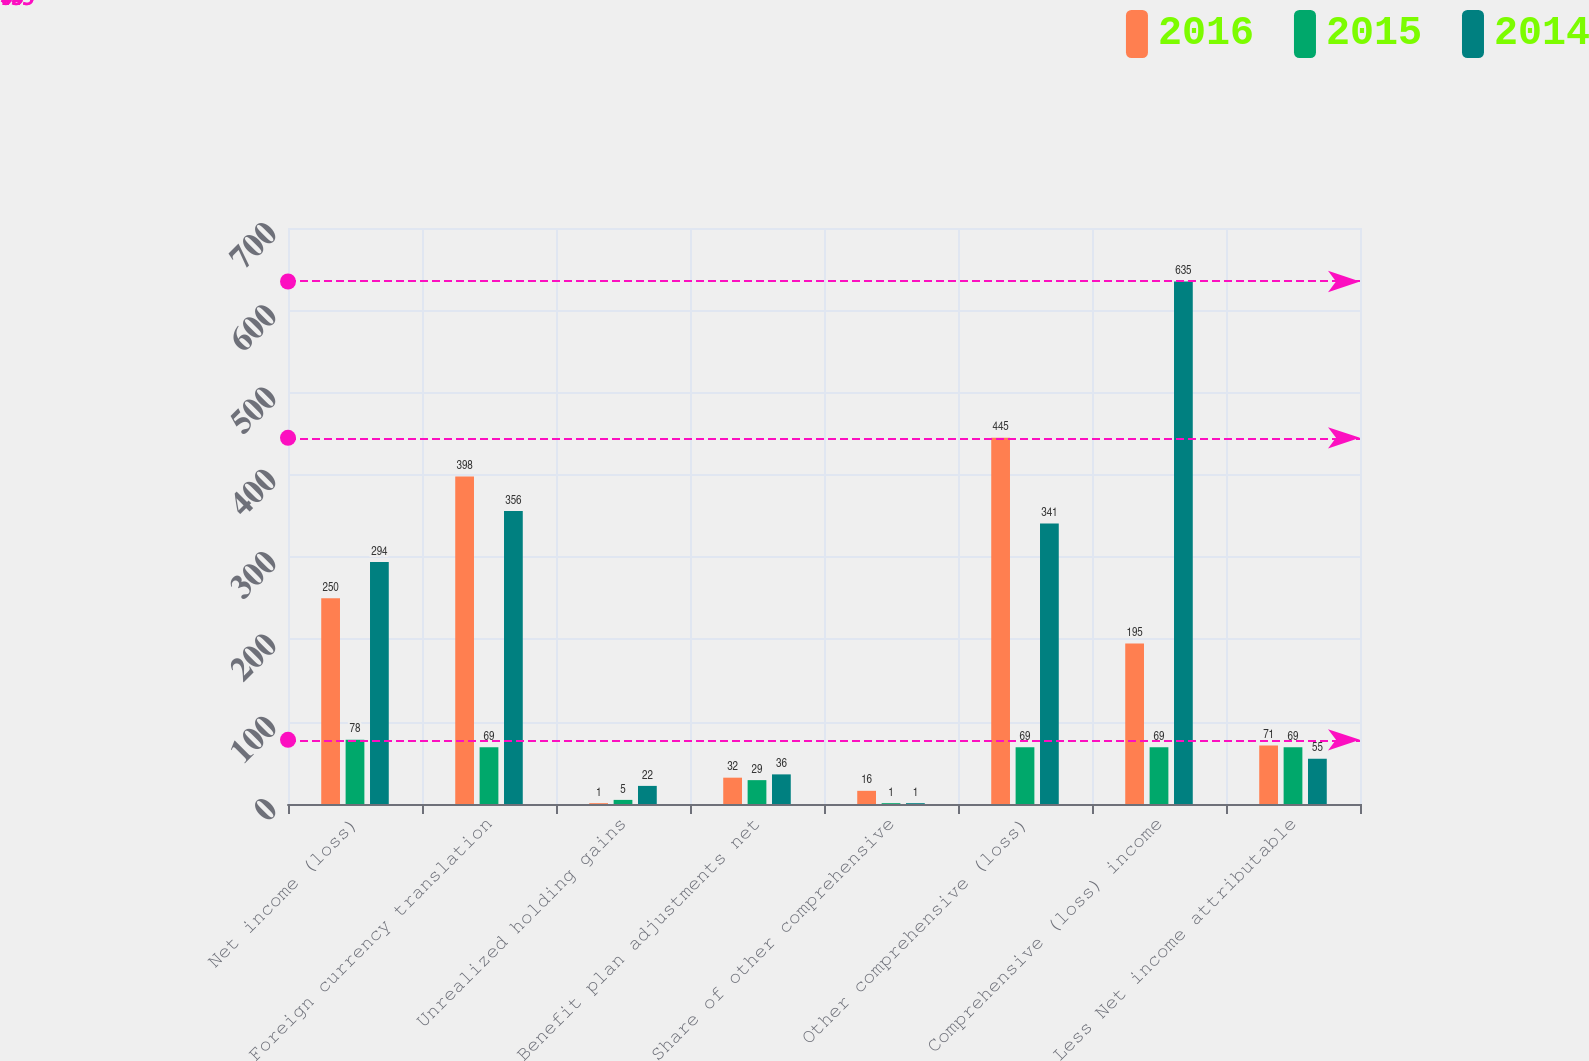<chart> <loc_0><loc_0><loc_500><loc_500><stacked_bar_chart><ecel><fcel>Net income (loss)<fcel>Foreign currency translation<fcel>Unrealized holding gains<fcel>Benefit plan adjustments net<fcel>Share of other comprehensive<fcel>Other comprehensive (loss)<fcel>Comprehensive (loss) income<fcel>Less Net income attributable<nl><fcel>2016<fcel>250<fcel>398<fcel>1<fcel>32<fcel>16<fcel>445<fcel>195<fcel>71<nl><fcel>2015<fcel>78<fcel>69<fcel>5<fcel>29<fcel>1<fcel>69<fcel>69<fcel>69<nl><fcel>2014<fcel>294<fcel>356<fcel>22<fcel>36<fcel>1<fcel>341<fcel>635<fcel>55<nl></chart> 